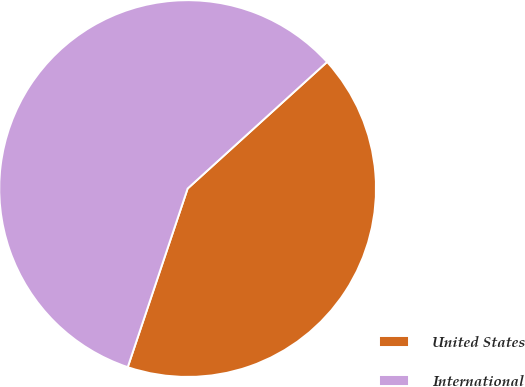<chart> <loc_0><loc_0><loc_500><loc_500><pie_chart><fcel>United States<fcel>International<nl><fcel>41.88%<fcel>58.12%<nl></chart> 